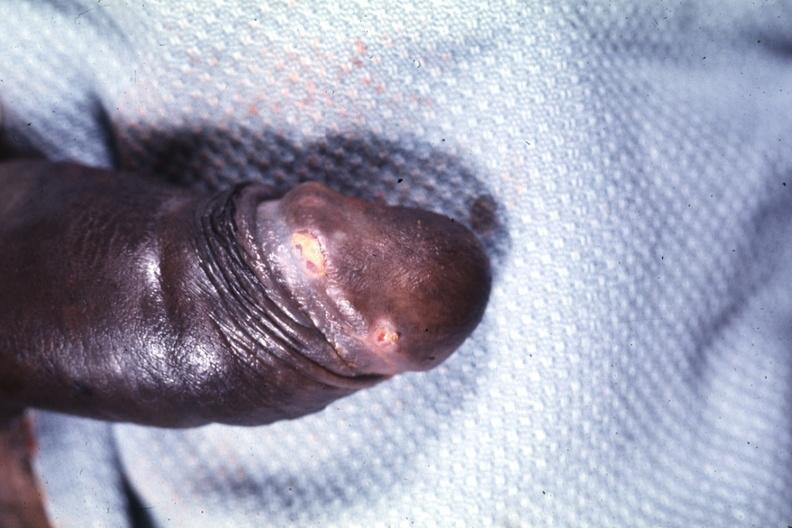does pulmonary osteoarthropathy show glans ulcers probable herpes?
Answer the question using a single word or phrase. No 